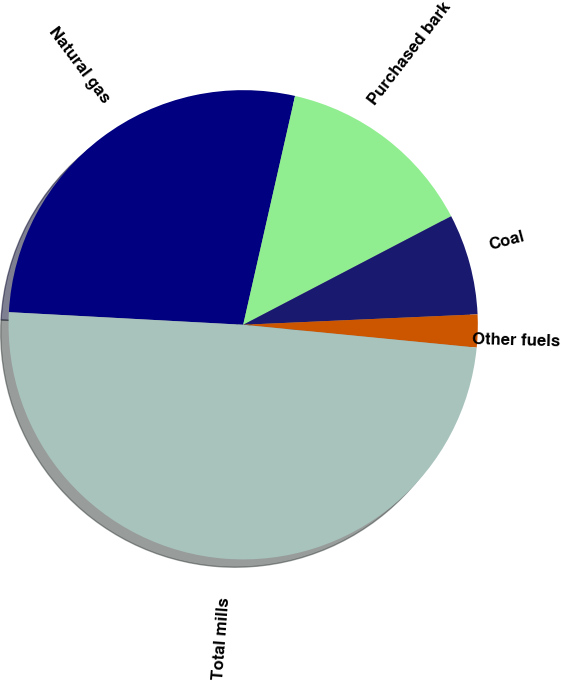Convert chart. <chart><loc_0><loc_0><loc_500><loc_500><pie_chart><fcel>Natural gas<fcel>Purchased bark<fcel>Coal<fcel>Other fuels<fcel>Total mills<nl><fcel>27.69%<fcel>13.79%<fcel>6.95%<fcel>2.26%<fcel>49.3%<nl></chart> 